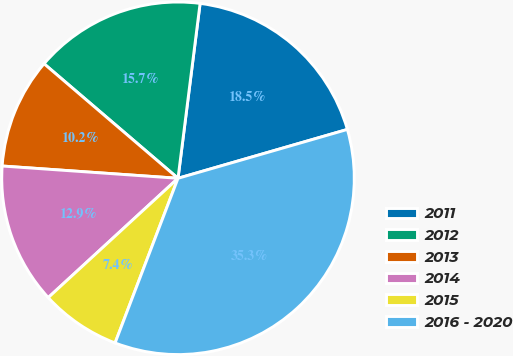<chart> <loc_0><loc_0><loc_500><loc_500><pie_chart><fcel>2011<fcel>2012<fcel>2013<fcel>2014<fcel>2015<fcel>2016 - 2020<nl><fcel>18.53%<fcel>15.74%<fcel>10.15%<fcel>12.94%<fcel>7.36%<fcel>35.28%<nl></chart> 